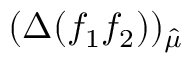<formula> <loc_0><loc_0><loc_500><loc_500>( \Delta ( f _ { 1 } f _ { 2 } ) ) _ { \hat { \mu } }</formula> 